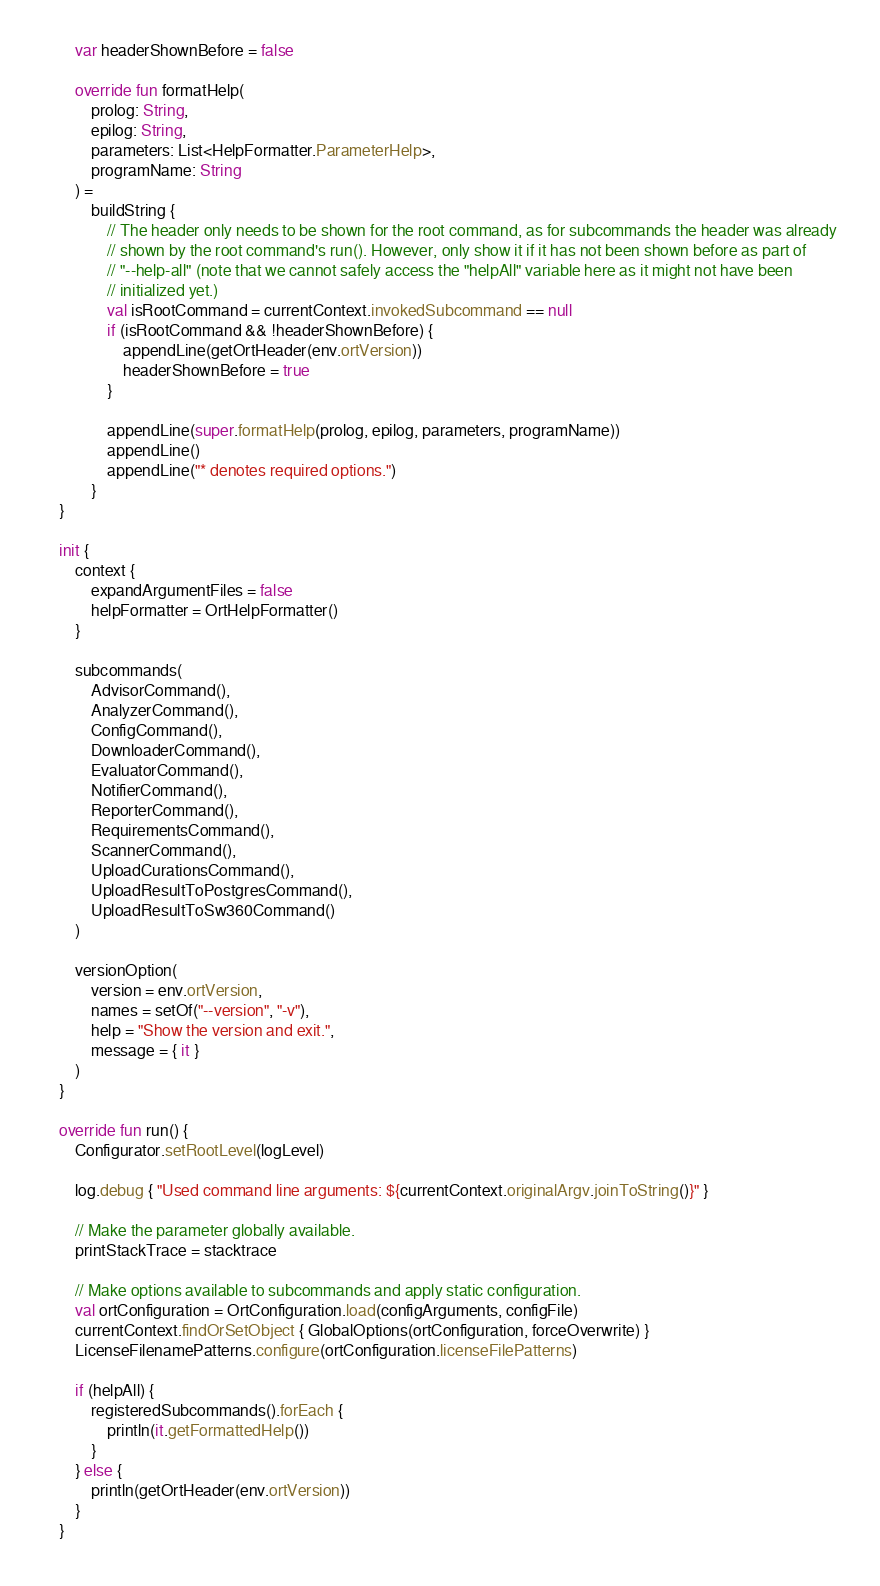Convert code to text. <code><loc_0><loc_0><loc_500><loc_500><_Kotlin_>        var headerShownBefore = false

        override fun formatHelp(
            prolog: String,
            epilog: String,
            parameters: List<HelpFormatter.ParameterHelp>,
            programName: String
        ) =
            buildString {
                // The header only needs to be shown for the root command, as for subcommands the header was already
                // shown by the root command's run(). However, only show it if it has not been shown before as part of
                // "--help-all" (note that we cannot safely access the "helpAll" variable here as it might not have been
                // initialized yet.)
                val isRootCommand = currentContext.invokedSubcommand == null
                if (isRootCommand && !headerShownBefore) {
                    appendLine(getOrtHeader(env.ortVersion))
                    headerShownBefore = true
                }

                appendLine(super.formatHelp(prolog, epilog, parameters, programName))
                appendLine()
                appendLine("* denotes required options.")
            }
    }

    init {
        context {
            expandArgumentFiles = false
            helpFormatter = OrtHelpFormatter()
        }

        subcommands(
            AdvisorCommand(),
            AnalyzerCommand(),
            ConfigCommand(),
            DownloaderCommand(),
            EvaluatorCommand(),
            NotifierCommand(),
            ReporterCommand(),
            RequirementsCommand(),
            ScannerCommand(),
            UploadCurationsCommand(),
            UploadResultToPostgresCommand(),
            UploadResultToSw360Command()
        )

        versionOption(
            version = env.ortVersion,
            names = setOf("--version", "-v"),
            help = "Show the version and exit.",
            message = { it }
        )
    }

    override fun run() {
        Configurator.setRootLevel(logLevel)

        log.debug { "Used command line arguments: ${currentContext.originalArgv.joinToString()}" }

        // Make the parameter globally available.
        printStackTrace = stacktrace

        // Make options available to subcommands and apply static configuration.
        val ortConfiguration = OrtConfiguration.load(configArguments, configFile)
        currentContext.findOrSetObject { GlobalOptions(ortConfiguration, forceOverwrite) }
        LicenseFilenamePatterns.configure(ortConfiguration.licenseFilePatterns)

        if (helpAll) {
            registeredSubcommands().forEach {
                println(it.getFormattedHelp())
            }
        } else {
            println(getOrtHeader(env.ortVersion))
        }
    }
</code> 